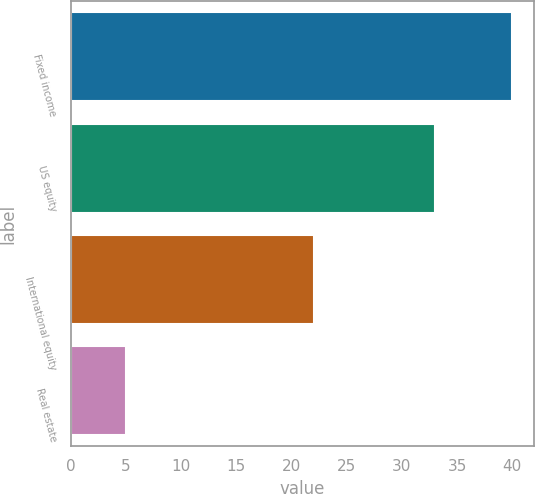Convert chart to OTSL. <chart><loc_0><loc_0><loc_500><loc_500><bar_chart><fcel>Fixed income<fcel>US equity<fcel>International equity<fcel>Real estate<nl><fcel>40<fcel>33<fcel>22<fcel>5<nl></chart> 